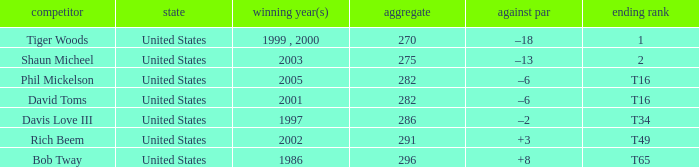Parse the full table. {'header': ['competitor', 'state', 'winning year(s)', 'aggregate', 'against par', 'ending rank'], 'rows': [['Tiger Woods', 'United States', '1999 , 2000', '270', '–18', '1'], ['Shaun Micheel', 'United States', '2003', '275', '–13', '2'], ['Phil Mickelson', 'United States', '2005', '282', '–6', 'T16'], ['David Toms', 'United States', '2001', '282', '–6', 'T16'], ['Davis Love III', 'United States', '1997', '286', '–2', 'T34'], ['Rich Beem', 'United States', '2002', '291', '+3', 'T49'], ['Bob Tway', 'United States', '1986', '296', '+8', 'T65']]} What is the to par number of the person who won in 2003? –13. 